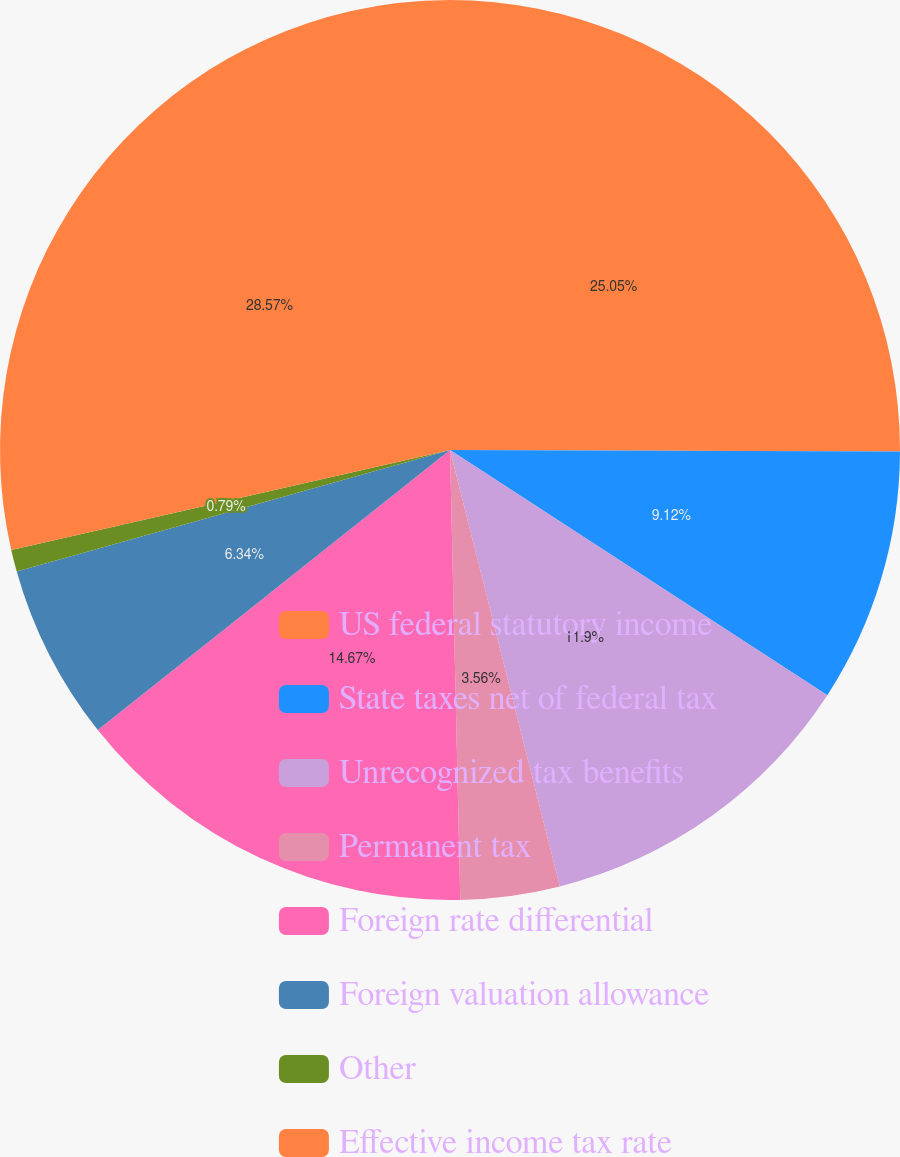Convert chart. <chart><loc_0><loc_0><loc_500><loc_500><pie_chart><fcel>US federal statutory income<fcel>State taxes net of federal tax<fcel>Unrecognized tax benefits<fcel>Permanent tax<fcel>Foreign rate differential<fcel>Foreign valuation allowance<fcel>Other<fcel>Effective income tax rate<nl><fcel>25.05%<fcel>9.12%<fcel>11.9%<fcel>3.56%<fcel>14.67%<fcel>6.34%<fcel>0.79%<fcel>28.56%<nl></chart> 